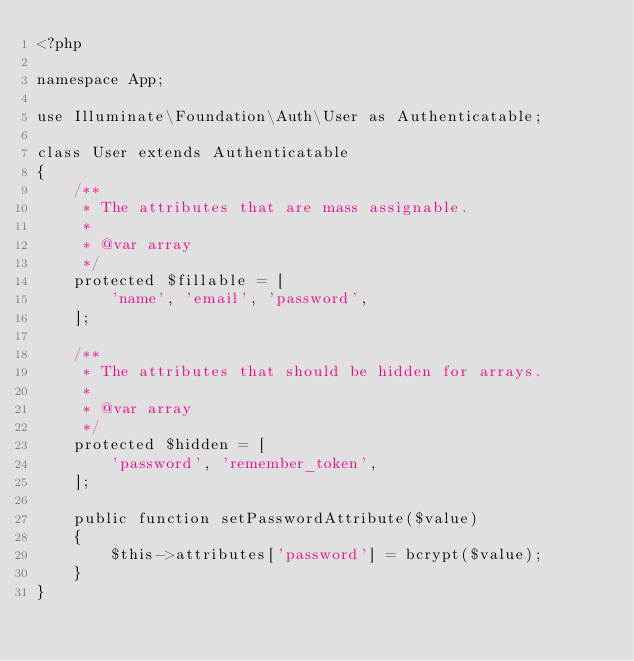<code> <loc_0><loc_0><loc_500><loc_500><_PHP_><?php

namespace App;

use Illuminate\Foundation\Auth\User as Authenticatable;

class User extends Authenticatable
{
    /**
     * The attributes that are mass assignable.
     *
     * @var array
     */
    protected $fillable = [
        'name', 'email', 'password',
    ];

    /**
     * The attributes that should be hidden for arrays.
     *
     * @var array
     */
    protected $hidden = [
        'password', 'remember_token',
    ];

    public function setPasswordAttribute($value)
    {
        $this->attributes['password'] = bcrypt($value);
    }
}
</code> 